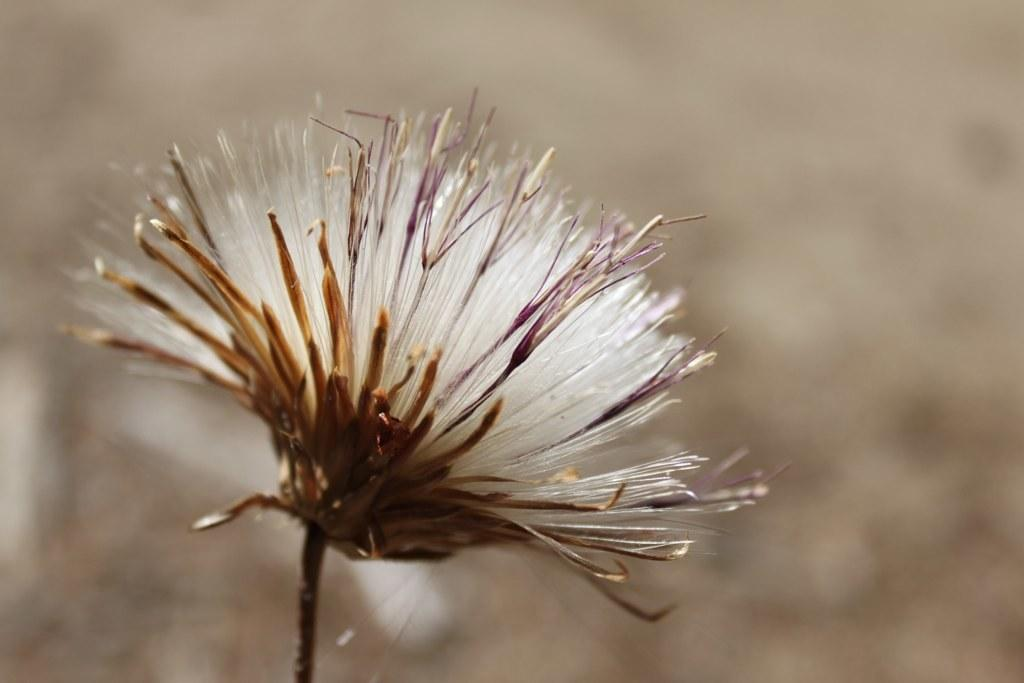What is the main subject of the image? The main subject of the image is a flower. Can you describe the flower in more detail? The flower is attached to a stem. What can be observed about the background of the image? The background of the image is blurred. How many pigs are participating in the voyage depicted in the image? There are no pigs or voyages depicted in the image; it features a flower with a blurred background. 